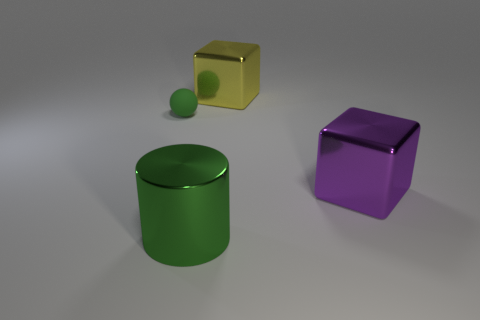What might be the context or purpose of these objects being together? This arrangement of objects could be part of a visual graphics test or a demonstration of 3D modeling and rendering capabilities, showcasing different shapes, colors, and reflections. Is there anything that distinguishes the yellow cube from the others? The yellow cube is unique due to its transparency and the fact that it has a hollow center, unlike the solid green cylinder and purple cube. 